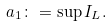<formula> <loc_0><loc_0><loc_500><loc_500>a _ { 1 } \colon = \sup I _ { L } .</formula> 